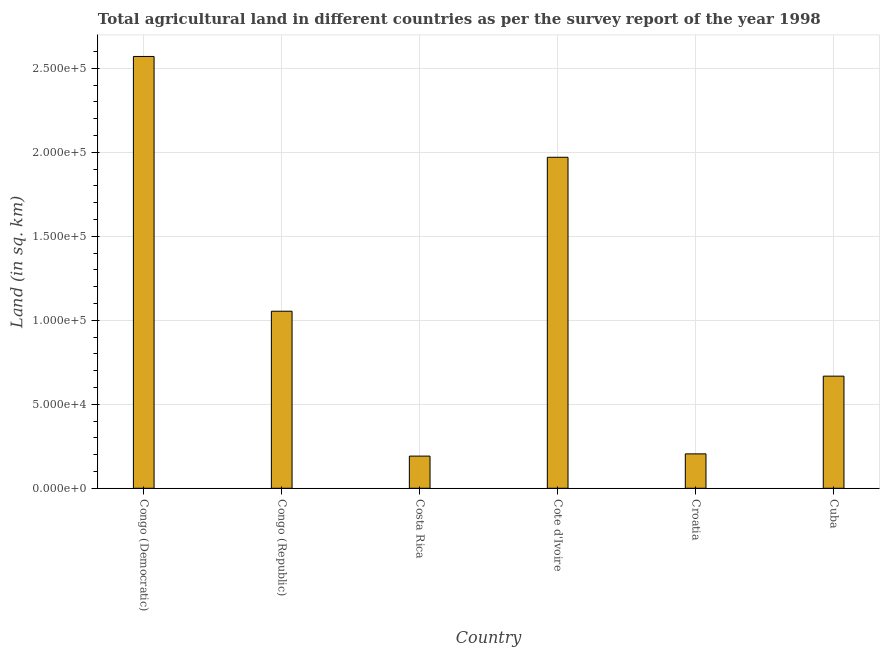Does the graph contain any zero values?
Offer a terse response. No. Does the graph contain grids?
Give a very brief answer. Yes. What is the title of the graph?
Give a very brief answer. Total agricultural land in different countries as per the survey report of the year 1998. What is the label or title of the X-axis?
Your answer should be compact. Country. What is the label or title of the Y-axis?
Your answer should be compact. Land (in sq. km). What is the agricultural land in Cuba?
Your response must be concise. 6.67e+04. Across all countries, what is the maximum agricultural land?
Your answer should be compact. 2.57e+05. Across all countries, what is the minimum agricultural land?
Keep it short and to the point. 1.92e+04. In which country was the agricultural land maximum?
Make the answer very short. Congo (Democratic). In which country was the agricultural land minimum?
Your answer should be very brief. Costa Rica. What is the sum of the agricultural land?
Give a very brief answer. 6.66e+05. What is the difference between the agricultural land in Congo (Democratic) and Croatia?
Offer a terse response. 2.37e+05. What is the average agricultural land per country?
Your answer should be very brief. 1.11e+05. What is the median agricultural land?
Offer a terse response. 8.61e+04. What is the ratio of the agricultural land in Congo (Republic) to that in Costa Rica?
Your response must be concise. 5.5. What is the difference between the highest and the lowest agricultural land?
Keep it short and to the point. 2.38e+05. In how many countries, is the agricultural land greater than the average agricultural land taken over all countries?
Give a very brief answer. 2. How many bars are there?
Offer a very short reply. 6. Are all the bars in the graph horizontal?
Provide a succinct answer. No. What is the Land (in sq. km) in Congo (Democratic)?
Your answer should be very brief. 2.57e+05. What is the Land (in sq. km) of Congo (Republic)?
Provide a succinct answer. 1.05e+05. What is the Land (in sq. km) in Costa Rica?
Ensure brevity in your answer.  1.92e+04. What is the Land (in sq. km) of Cote d'Ivoire?
Keep it short and to the point. 1.97e+05. What is the Land (in sq. km) of Croatia?
Keep it short and to the point. 2.05e+04. What is the Land (in sq. km) of Cuba?
Offer a terse response. 6.67e+04. What is the difference between the Land (in sq. km) in Congo (Democratic) and Congo (Republic)?
Provide a short and direct response. 1.52e+05. What is the difference between the Land (in sq. km) in Congo (Democratic) and Costa Rica?
Your answer should be compact. 2.38e+05. What is the difference between the Land (in sq. km) in Congo (Democratic) and Cote d'Ivoire?
Offer a terse response. 6.00e+04. What is the difference between the Land (in sq. km) in Congo (Democratic) and Croatia?
Ensure brevity in your answer.  2.37e+05. What is the difference between the Land (in sq. km) in Congo (Democratic) and Cuba?
Offer a very short reply. 1.90e+05. What is the difference between the Land (in sq. km) in Congo (Republic) and Costa Rica?
Make the answer very short. 8.62e+04. What is the difference between the Land (in sq. km) in Congo (Republic) and Cote d'Ivoire?
Your response must be concise. -9.16e+04. What is the difference between the Land (in sq. km) in Congo (Republic) and Croatia?
Give a very brief answer. 8.49e+04. What is the difference between the Land (in sq. km) in Congo (Republic) and Cuba?
Offer a very short reply. 3.86e+04. What is the difference between the Land (in sq. km) in Costa Rica and Cote d'Ivoire?
Your response must be concise. -1.78e+05. What is the difference between the Land (in sq. km) in Costa Rica and Croatia?
Your answer should be compact. -1330. What is the difference between the Land (in sq. km) in Costa Rica and Cuba?
Offer a very short reply. -4.76e+04. What is the difference between the Land (in sq. km) in Cote d'Ivoire and Croatia?
Give a very brief answer. 1.77e+05. What is the difference between the Land (in sq. km) in Cote d'Ivoire and Cuba?
Provide a succinct answer. 1.30e+05. What is the difference between the Land (in sq. km) in Croatia and Cuba?
Offer a terse response. -4.63e+04. What is the ratio of the Land (in sq. km) in Congo (Democratic) to that in Congo (Republic)?
Make the answer very short. 2.44. What is the ratio of the Land (in sq. km) in Congo (Democratic) to that in Costa Rica?
Make the answer very short. 13.42. What is the ratio of the Land (in sq. km) in Congo (Democratic) to that in Cote d'Ivoire?
Provide a succinct answer. 1.3. What is the ratio of the Land (in sq. km) in Congo (Democratic) to that in Croatia?
Ensure brevity in your answer.  12.55. What is the ratio of the Land (in sq. km) in Congo (Democratic) to that in Cuba?
Offer a very short reply. 3.85. What is the ratio of the Land (in sq. km) in Congo (Republic) to that in Costa Rica?
Provide a succinct answer. 5.5. What is the ratio of the Land (in sq. km) in Congo (Republic) to that in Cote d'Ivoire?
Your answer should be compact. 0.54. What is the ratio of the Land (in sq. km) in Congo (Republic) to that in Croatia?
Provide a short and direct response. 5.15. What is the ratio of the Land (in sq. km) in Congo (Republic) to that in Cuba?
Offer a terse response. 1.58. What is the ratio of the Land (in sq. km) in Costa Rica to that in Cote d'Ivoire?
Provide a short and direct response. 0.1. What is the ratio of the Land (in sq. km) in Costa Rica to that in Croatia?
Ensure brevity in your answer.  0.94. What is the ratio of the Land (in sq. km) in Costa Rica to that in Cuba?
Give a very brief answer. 0.29. What is the ratio of the Land (in sq. km) in Cote d'Ivoire to that in Croatia?
Offer a terse response. 9.62. What is the ratio of the Land (in sq. km) in Cote d'Ivoire to that in Cuba?
Make the answer very short. 2.95. What is the ratio of the Land (in sq. km) in Croatia to that in Cuba?
Your answer should be very brief. 0.31. 